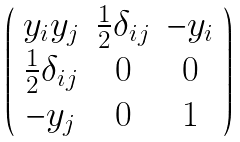Convert formula to latex. <formula><loc_0><loc_0><loc_500><loc_500>\left ( \begin{array} { c c c } y _ { i } y _ { j } & \frac { 1 } { 2 } \delta _ { i j } & - y _ { i } \\ \frac { 1 } { 2 } \delta _ { i j } & 0 & 0 \\ - y _ { j } & 0 & 1 \\ \end{array} \right )</formula> 